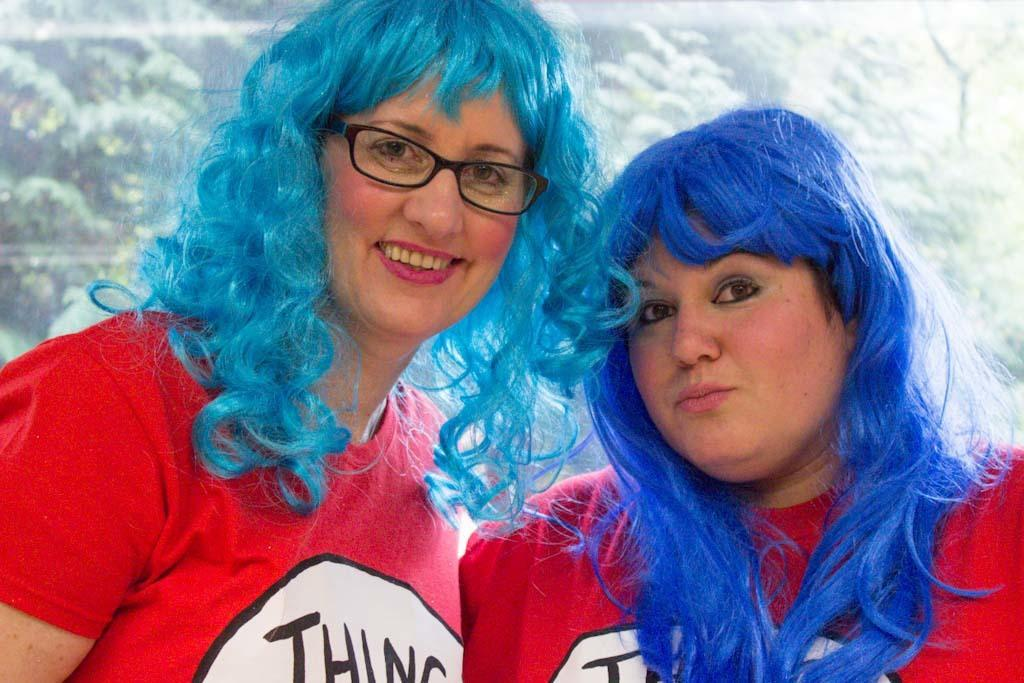How many people are in the image? There are two persons in the image. What are the people wearing? Both persons are wearing red shirts. Can you describe any distinguishing features of the person on the left side? The person on the left side is wearing spectacles. What can be seen in the background of the image? There are trees visible in the background of the image. How many folds can be seen in the person's shirt on the right side? There is no mention of folds in the shirt of the person on the right side, and therefore we cannot determine the number of folds. Are there any clams visible in the image? There are no clams present in the image. 